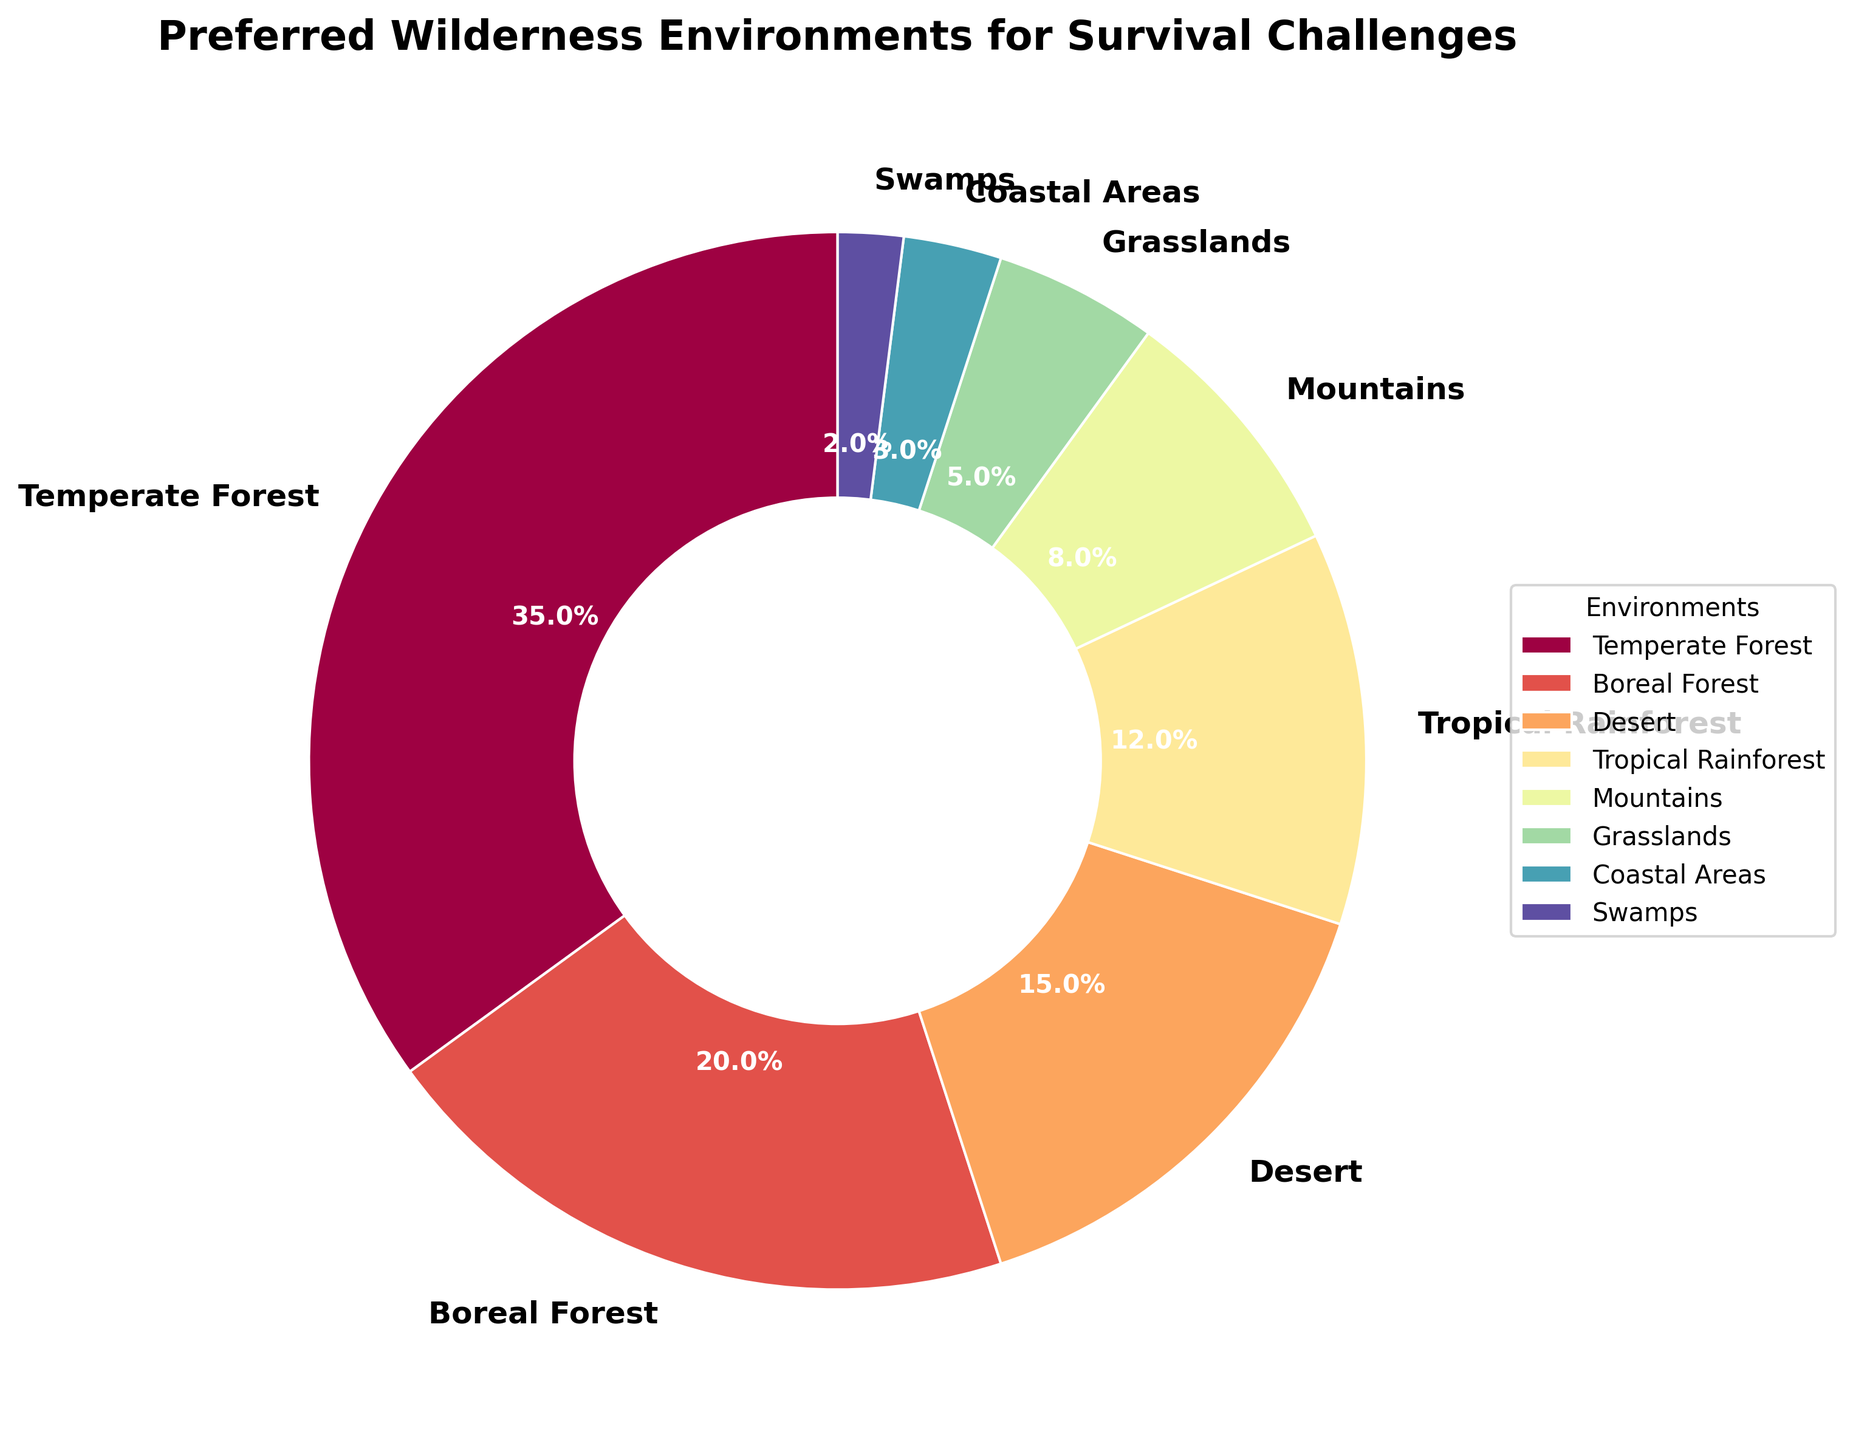Which environment is the most preferred for survival challenges? The pie chart shows that the Temperate Forest segment is the largest, indicating it has the highest percentage.
Answer: Temperate Forest Which two environments together make up half (50%) of the preferences? Adding the Temperate Forest (35%) and Boreal Forest (20%) together gives 55%, which is more than half. So, slightly less than half would include Temperate Forest and the next highest.
Answer: Temperate Forest and Boreal Forest How much more preferable is the Temperate Forest compared to Coastal Areas? The Temperate Forest is at 35%, while Coastal Areas are at 3%. The difference between them is 35% - 3% = 32%.
Answer: 32% Which environment has the least preference for survival challenges? The smallest segment on the pie chart is Swamps, indicating it has the lowest percentage.
Answer: Swamps Are there more preferences for Desert or Tropical Rainforest environments? Looking at the pie chart, the Desert segment is larger than the Tropical Rainforest segment.
Answer: Desert What is the combined preference percentage for Mountains, Grasslands, and Coastal Areas? The combined percentage is the sum of the individual percentages: Mountains (8%) + Grasslands (5%) + Coastal Areas (3%) = 16%.
Answer: 16% How much less preferable is the Tropical Rainforest compared to Boreal Forest? The Boreal Forest is at 20% while Tropical Rainforest is at 12%. The difference is 20% - 12% = 8%.
Answer: 8% Which areas together form exactly one-fifth of the total preferences? We know one-fifth of 100% is 20%. The Boreal Forest has a 20% preference rate, so it alone forms exactly one-fifth.
Answer: Boreal Forest Between Grasslands and Swamps, which environment receives more preference and by how much? The Grasslands have a preference of 5%, and Swamps have 2%. The difference is 5% - 2% = 3%.
Answer: Grasslands by 3% What percentage of participants prefer either the Temperate or Boreal Forest? Temperate Forest (35%) + Boreal Forest (20%) = 55% of participants prefer either of these environments.
Answer: 55% 